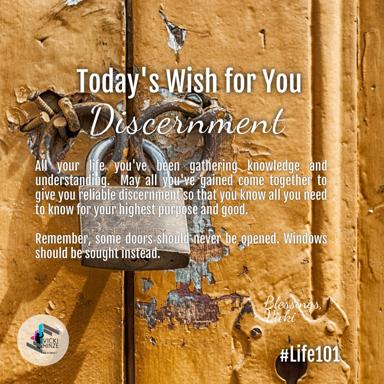What might be the significance of using the hashtag #Life101 in this context? The hashtag #Life101 implies that the wisdom shared about discernment and choosing between doors and windows is fundamental and essential, similar to an introductory course on life. It suggests that mastering such basic yet profound insights can significantly influence one's personal and professional fulfillment. 